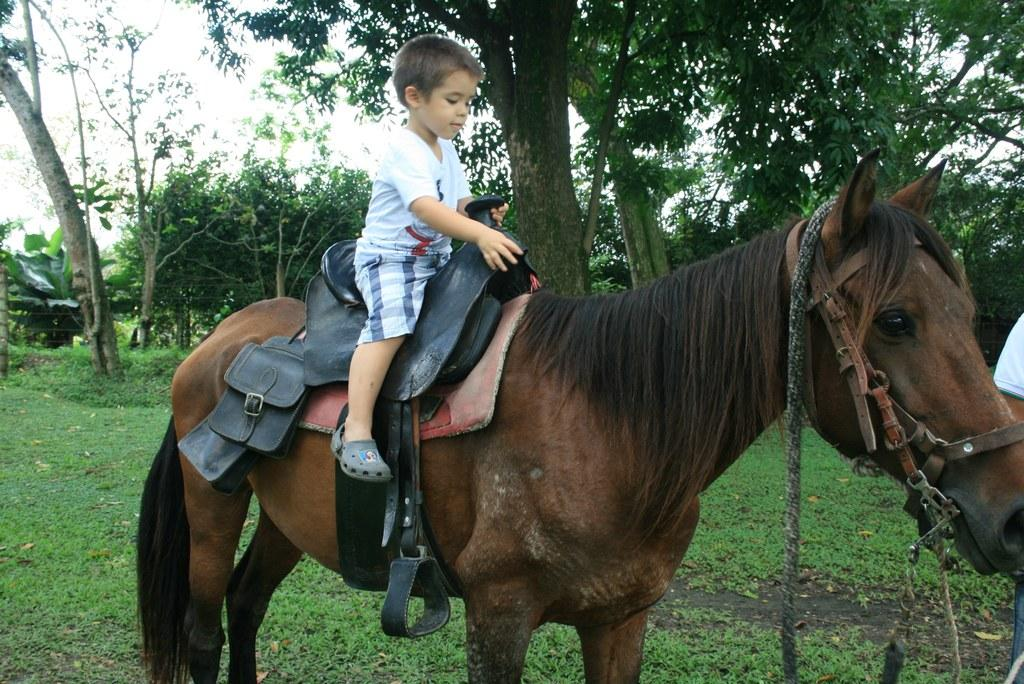What is the main subject of the image? The main subject of the image is a kid. What is the kid doing in the image? The kid is sitting on a horse. What can be seen in the background of the image? There are trees in the background of the image. What type of cheese is the kid holding in the image? There is no cheese present in the image; the kid is sitting on a horse. How many feet are visible in the image? The number of feet visible in the image cannot be determined from the provided facts, as the focus is on the kid sitting on a horse. 